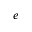Convert formula to latex. <formula><loc_0><loc_0><loc_500><loc_500>e</formula> 